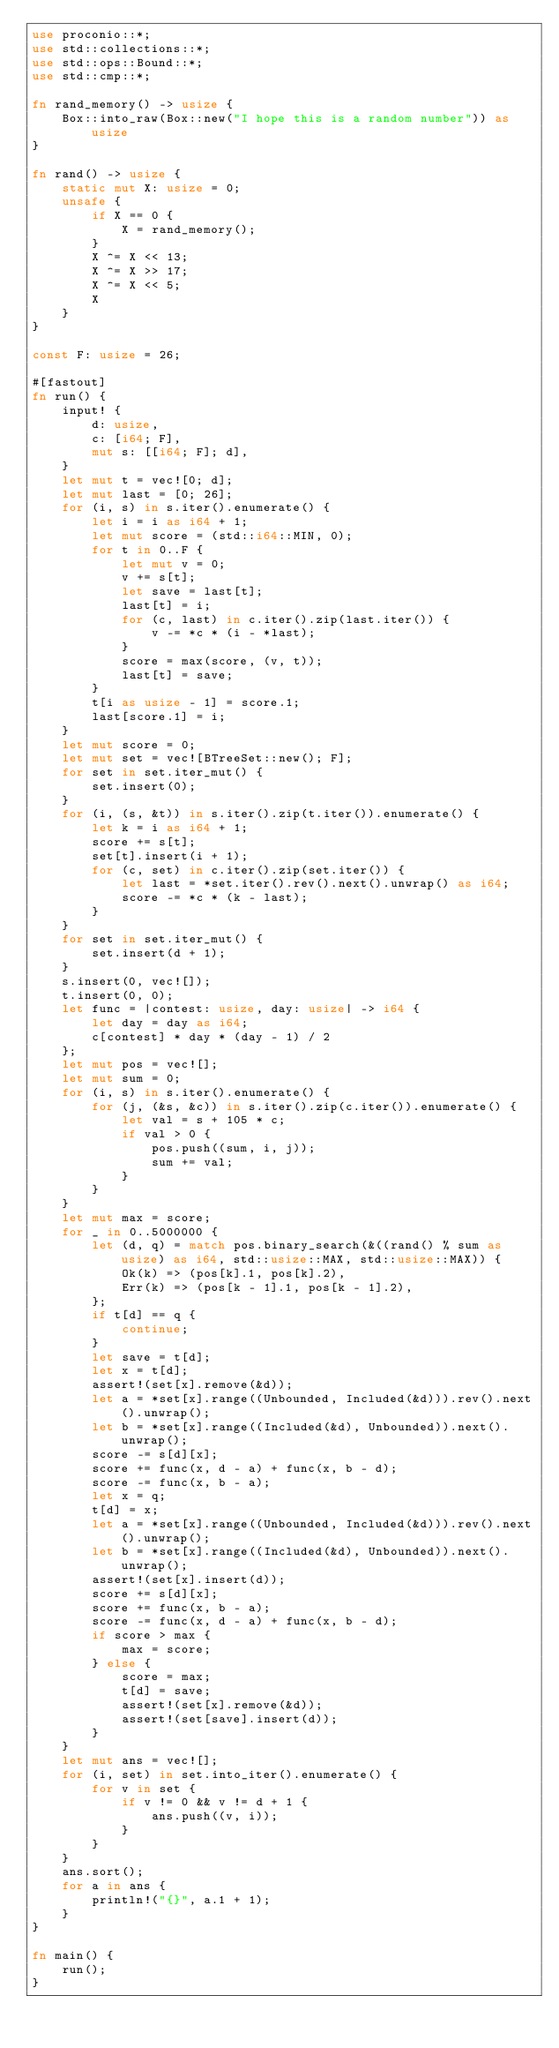<code> <loc_0><loc_0><loc_500><loc_500><_Rust_>use proconio::*;
use std::collections::*;
use std::ops::Bound::*;
use std::cmp::*;

fn rand_memory() -> usize {
    Box::into_raw(Box::new("I hope this is a random number")) as usize
}

fn rand() -> usize {
    static mut X: usize = 0;
    unsafe {
        if X == 0 {
            X = rand_memory();
        }
        X ^= X << 13;
        X ^= X >> 17;
        X ^= X << 5;
        X
    }
}

const F: usize = 26;

#[fastout]
fn run() {
    input! {
        d: usize,
        c: [i64; F],
        mut s: [[i64; F]; d],
    }
    let mut t = vec![0; d];
    let mut last = [0; 26];
    for (i, s) in s.iter().enumerate() {
        let i = i as i64 + 1;
        let mut score = (std::i64::MIN, 0);
        for t in 0..F {
            let mut v = 0;
            v += s[t];
            let save = last[t];
            last[t] = i;
            for (c, last) in c.iter().zip(last.iter()) {
                v -= *c * (i - *last);
            }
            score = max(score, (v, t));
            last[t] = save;
        }
        t[i as usize - 1] = score.1;
        last[score.1] = i;
    }
    let mut score = 0;
    let mut set = vec![BTreeSet::new(); F];
    for set in set.iter_mut() {
        set.insert(0);
    }
    for (i, (s, &t)) in s.iter().zip(t.iter()).enumerate() {
        let k = i as i64 + 1;
        score += s[t];
        set[t].insert(i + 1);
        for (c, set) in c.iter().zip(set.iter()) {
            let last = *set.iter().rev().next().unwrap() as i64;
            score -= *c * (k - last);
        }
    }
    for set in set.iter_mut() {
        set.insert(d + 1);
    }
    s.insert(0, vec![]);
    t.insert(0, 0);
    let func = |contest: usize, day: usize| -> i64 {
        let day = day as i64;
        c[contest] * day * (day - 1) / 2
    };
    let mut pos = vec![];
    let mut sum = 0;
    for (i, s) in s.iter().enumerate() {
        for (j, (&s, &c)) in s.iter().zip(c.iter()).enumerate() {
            let val = s + 105 * c;
            if val > 0 {
                pos.push((sum, i, j));
                sum += val;
            }
        }
    }
    let mut max = score;
    for _ in 0..5000000 {
        let (d, q) = match pos.binary_search(&((rand() % sum as usize) as i64, std::usize::MAX, std::usize::MAX)) {
            Ok(k) => (pos[k].1, pos[k].2),
            Err(k) => (pos[k - 1].1, pos[k - 1].2),
        };
        if t[d] == q {
            continue;
        }
        let save = t[d];
        let x = t[d];
        assert!(set[x].remove(&d));
        let a = *set[x].range((Unbounded, Included(&d))).rev().next().unwrap();
        let b = *set[x].range((Included(&d), Unbounded)).next().unwrap();
        score -= s[d][x];
        score += func(x, d - a) + func(x, b - d);
        score -= func(x, b - a);
        let x = q;
        t[d] = x;
        let a = *set[x].range((Unbounded, Included(&d))).rev().next().unwrap();
        let b = *set[x].range((Included(&d), Unbounded)).next().unwrap();
        assert!(set[x].insert(d));
        score += s[d][x];
        score += func(x, b - a);
        score -= func(x, d - a) + func(x, b - d);
        if score > max {
            max = score;
        } else {
            score = max;
            t[d] = save;
            assert!(set[x].remove(&d));
            assert!(set[save].insert(d));
        }
    }
    let mut ans = vec![];
    for (i, set) in set.into_iter().enumerate() {
        for v in set {
            if v != 0 && v != d + 1 {
                ans.push((v, i));
            }
        }
    }
    ans.sort();
    for a in ans {
        println!("{}", a.1 + 1);
    }
}

fn main() {
    run();
}
</code> 